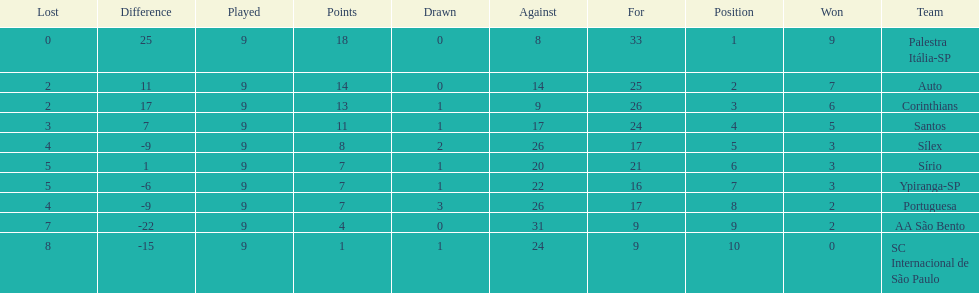Could you parse the entire table as a dict? {'header': ['Lost', 'Difference', 'Played', 'Points', 'Drawn', 'Against', 'For', 'Position', 'Won', 'Team'], 'rows': [['0', '25', '9', '18', '0', '8', '33', '1', '9', 'Palestra Itália-SP'], ['2', '11', '9', '14', '0', '14', '25', '2', '7', 'Auto'], ['2', '17', '9', '13', '1', '9', '26', '3', '6', 'Corinthians'], ['3', '7', '9', '11', '1', '17', '24', '4', '5', 'Santos'], ['4', '-9', '9', '8', '2', '26', '17', '5', '3', 'Sílex'], ['5', '1', '9', '7', '1', '20', '21', '6', '3', 'Sírio'], ['5', '-6', '9', '7', '1', '22', '16', '7', '3', 'Ypiranga-SP'], ['4', '-9', '9', '7', '3', '26', '17', '8', '2', 'Portuguesa'], ['7', '-22', '9', '4', '0', '31', '9', '9', '2', 'AA São Bento'], ['8', '-15', '9', '1', '1', '24', '9', '10', '0', 'SC Internacional de São Paulo']]} In 1926 brazilian football,aside from the first place team, what other teams had winning records? Auto, Corinthians, Santos. 